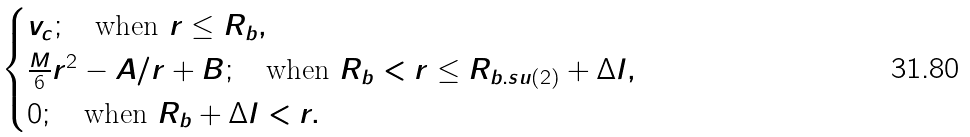Convert formula to latex. <formula><loc_0><loc_0><loc_500><loc_500>\begin{cases} v _ { c } ; \quad \text {when } r \leq R _ { b } , \\ \frac { M } { 6 } r ^ { 2 } - A / r + B ; \quad \text {when } R _ { b } < r \leq R _ { b . s u ( 2 ) } + \Delta l , \\ 0 ; \quad \text {when } R _ { b } + \Delta l < r . \end{cases}</formula> 